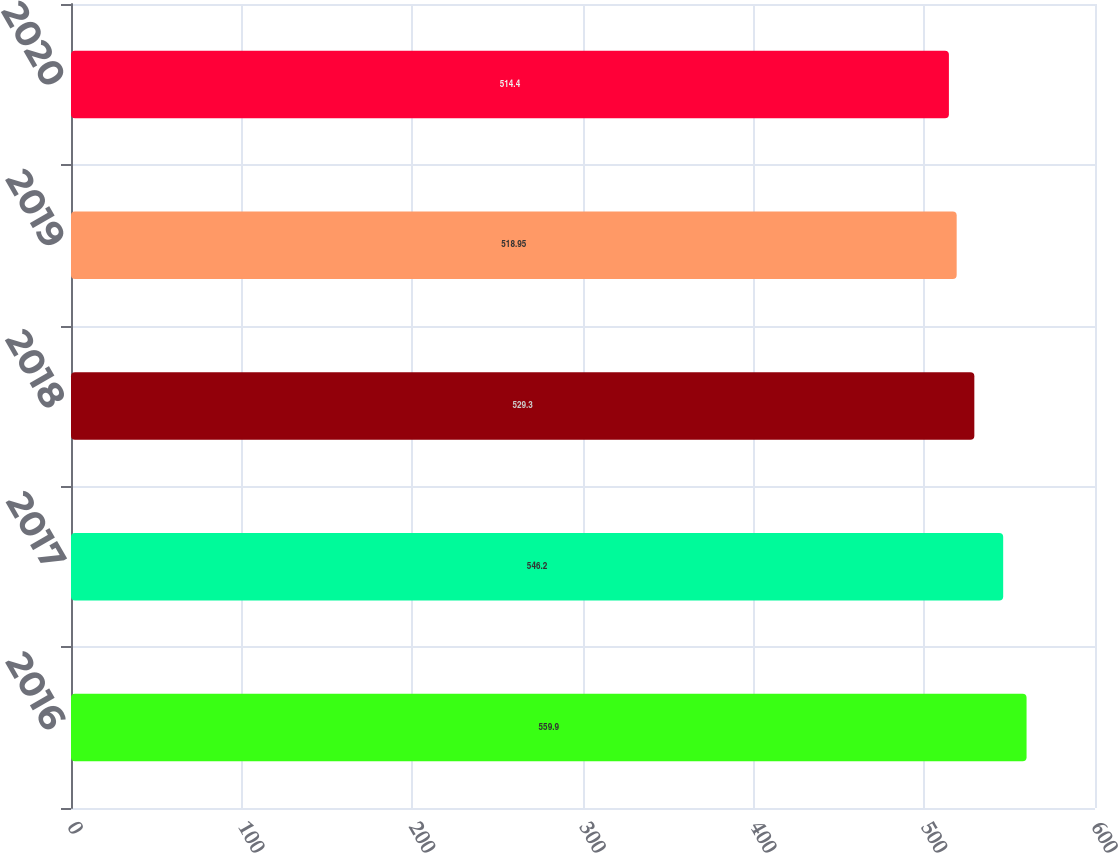Convert chart to OTSL. <chart><loc_0><loc_0><loc_500><loc_500><bar_chart><fcel>2016<fcel>2017<fcel>2018<fcel>2019<fcel>2020<nl><fcel>559.9<fcel>546.2<fcel>529.3<fcel>518.95<fcel>514.4<nl></chart> 